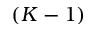<formula> <loc_0><loc_0><loc_500><loc_500>( K - 1 )</formula> 